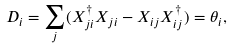<formula> <loc_0><loc_0><loc_500><loc_500>D _ { i } = \sum _ { j } ( X _ { j i } ^ { \dagger } X _ { j i } - X _ { i j } X _ { i j } ^ { \dagger } ) = \theta _ { i } ,</formula> 